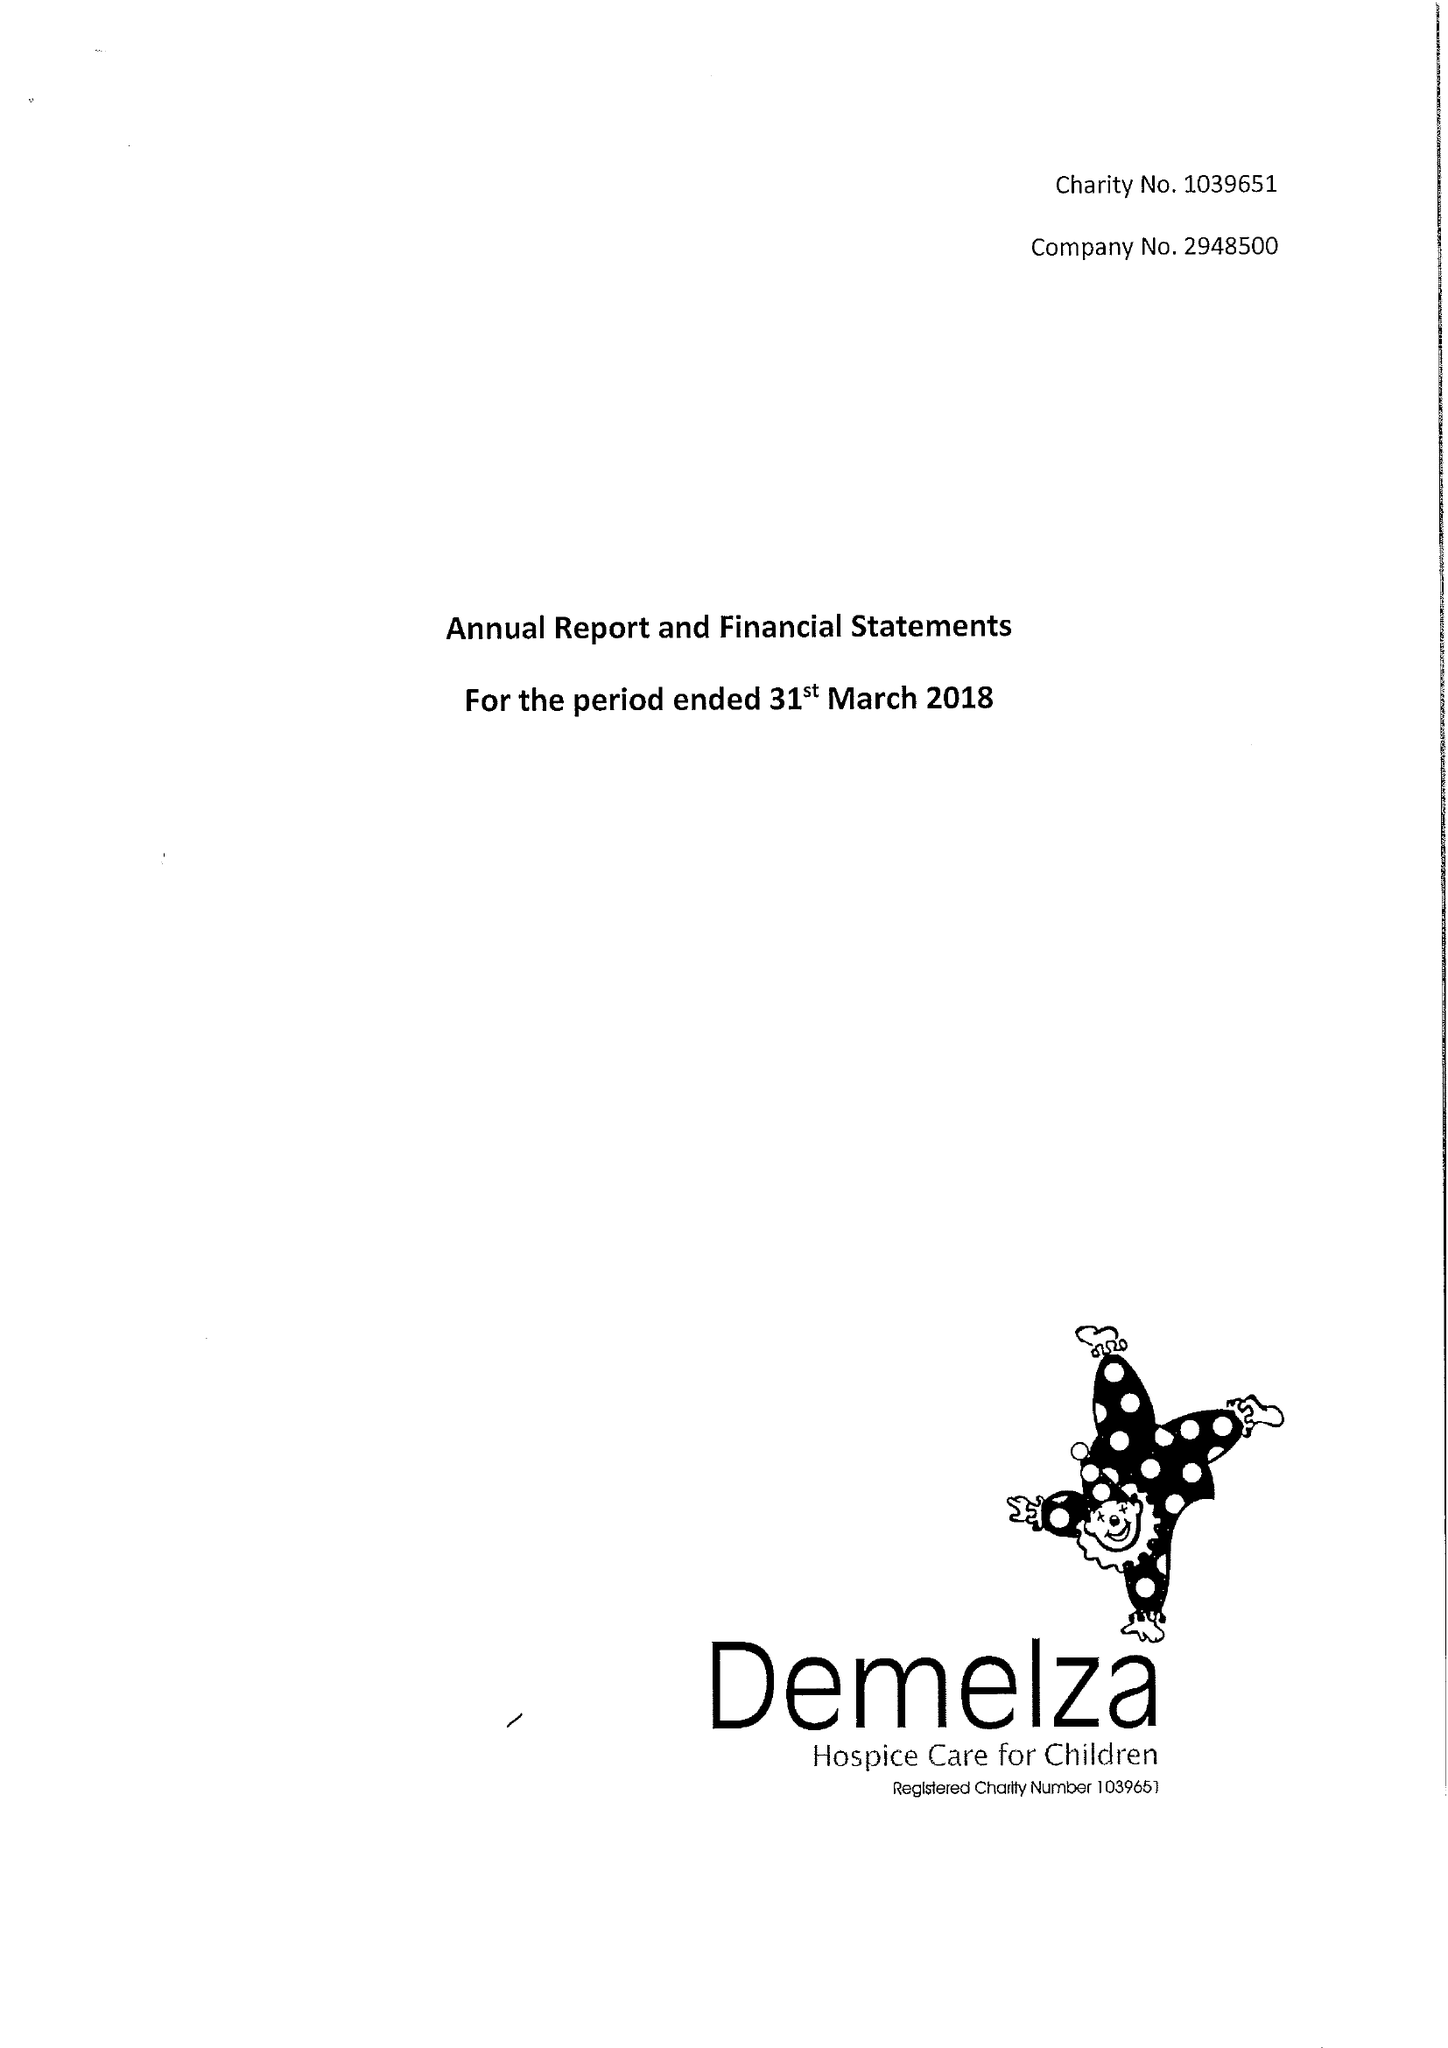What is the value for the spending_annually_in_british_pounds?
Answer the question using a single word or phrase. 10611820.00 